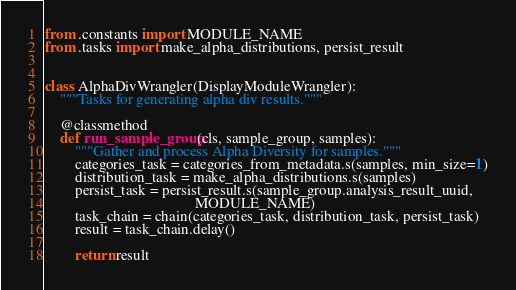Convert code to text. <code><loc_0><loc_0><loc_500><loc_500><_Python_>from .constants import MODULE_NAME
from .tasks import make_alpha_distributions, persist_result


class AlphaDivWrangler(DisplayModuleWrangler):
    """Tasks for generating alpha div results."""

    @classmethod
    def run_sample_group(cls, sample_group, samples):
        """Gather and process Alpha Diversity for samples."""
        categories_task = categories_from_metadata.s(samples, min_size=1)
        distribution_task = make_alpha_distributions.s(samples)
        persist_task = persist_result.s(sample_group.analysis_result_uuid,
                                        MODULE_NAME)
        task_chain = chain(categories_task, distribution_task, persist_task)
        result = task_chain.delay()

        return result
</code> 